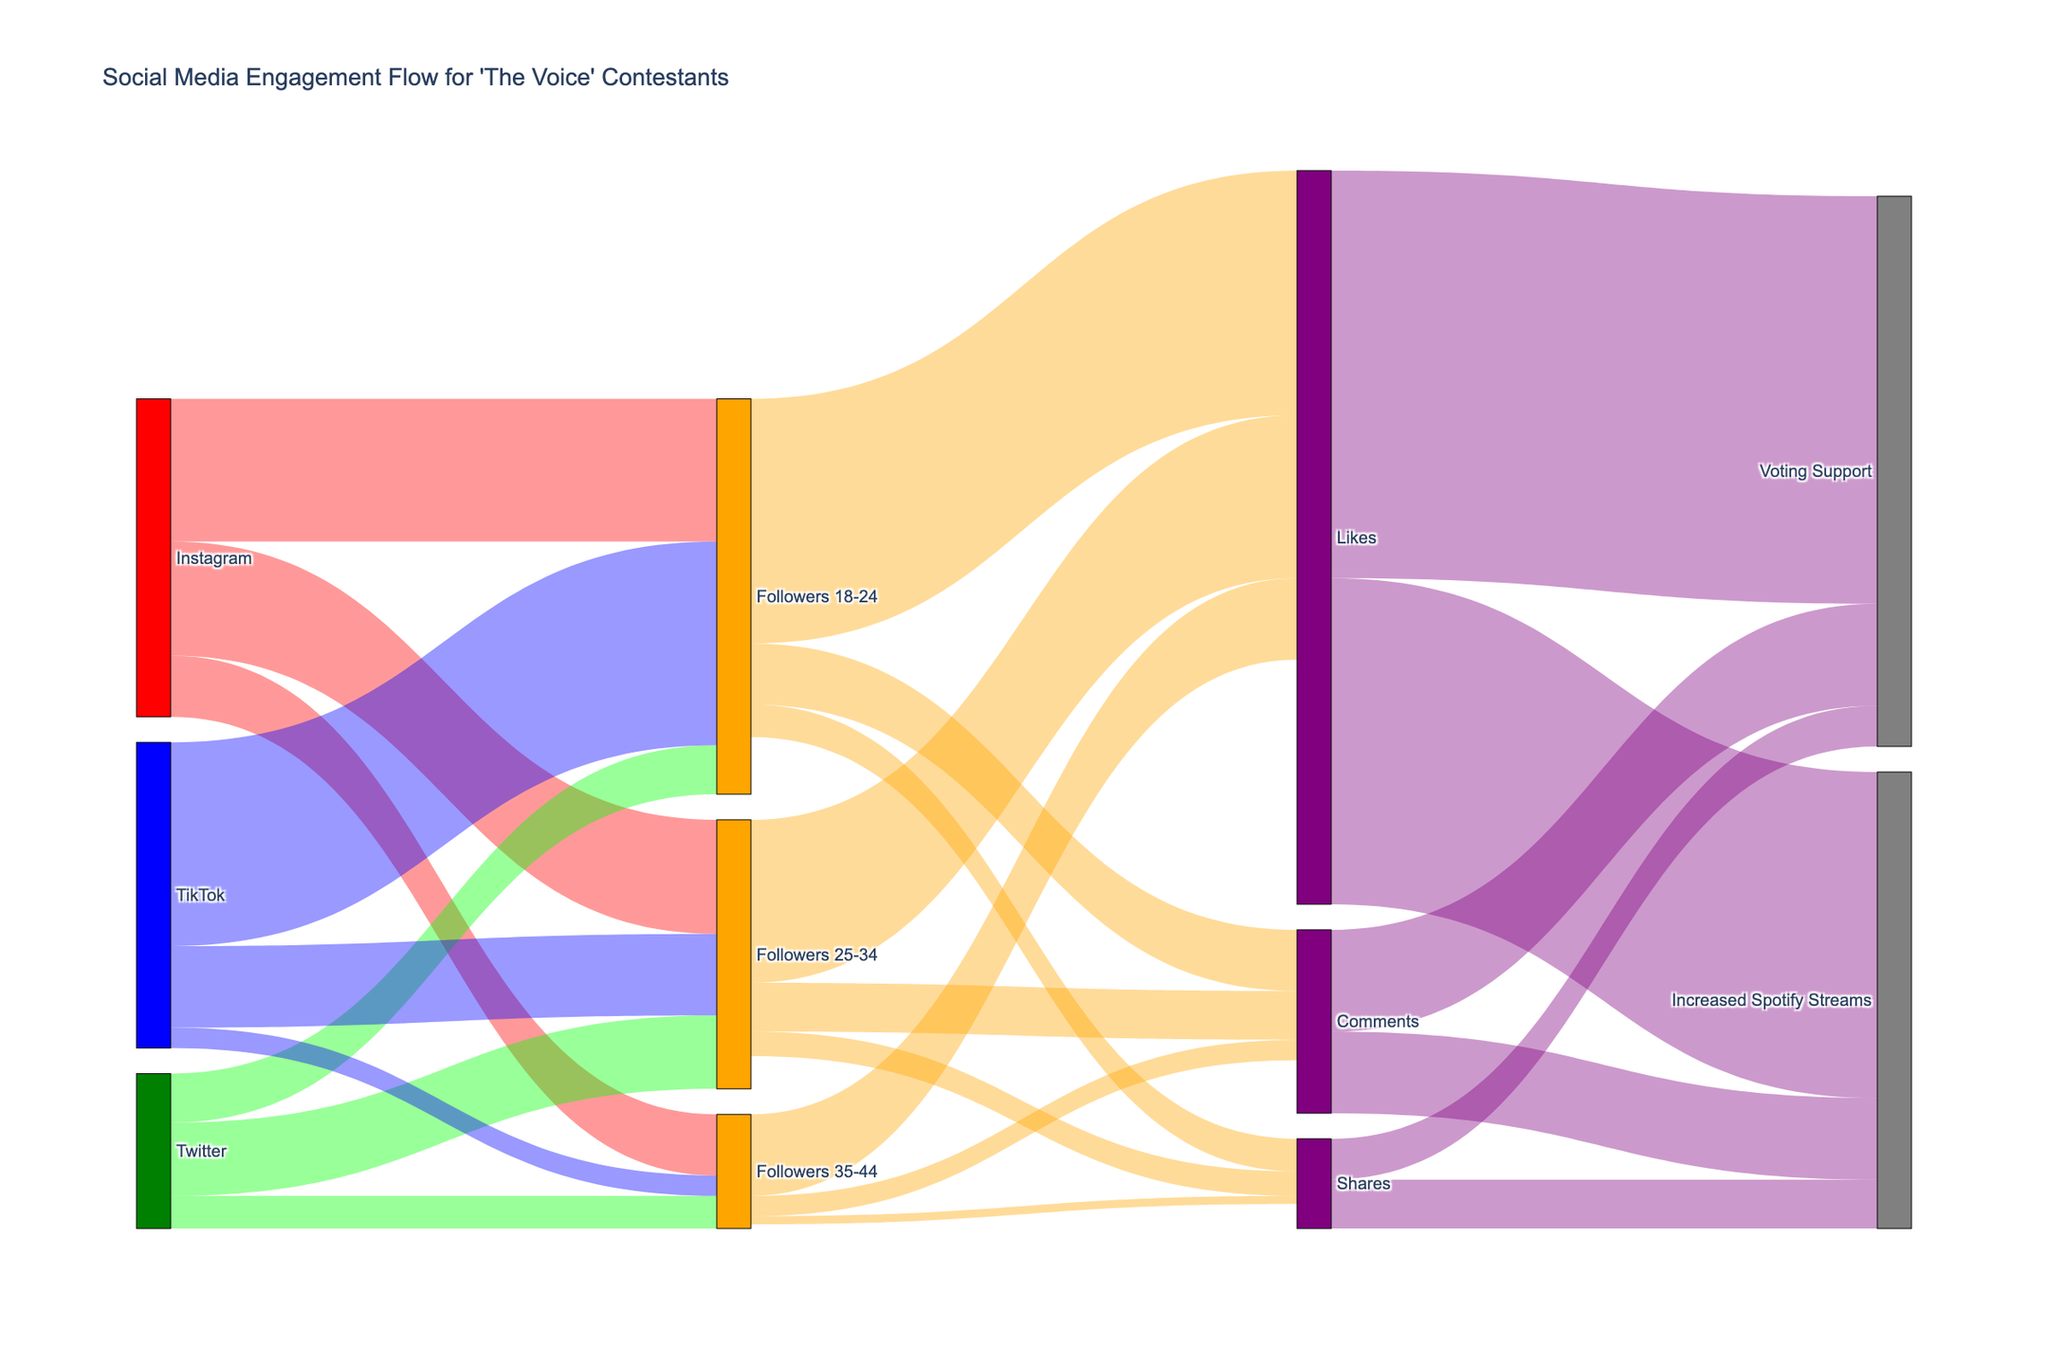What's the title of the diagram? The title is located at the top of the figure.
Answer: Social Media Engagement Flow for 'The Voice' Contestants Which social media platform has the highest number of followers in the 18-24 age group? Look for the platform-to-follower flow related to the 18-24 age group. The values are 35,000 for Instagram, 12,000 for Twitter, and 50,000 for TikTok.
Answer: TikTok How many likes are given by followers aged 25-34 overall? Find the flow values from 'Followers 25-34' to 'Likes'. The value is 40,000.
Answer: 40,000 Compare the number of comments given by followers aged 18-24 to those given by followers aged 35-44. Which group gives more comments? Look at the 'Comments' flow values for 'Followers 18-24' and 'Followers 35-44'. The values are 15,000 and 5,000 respectively.
Answer: Followers 18-24 What is the total number of increased Spotify streams originating from social media interactions? Add the values for 'Increased Spotify Streams' from 'Likes' (80,000), 'Comments' (20,000), and 'Shares' (12,000).
Answer: 112,000 Which age group has the least number of followers across all platforms? Compare the summed values of each age group's flow from all platforms: 
18-24: 35,000 (IG) + 12,000 (TW) + 50,000 (TT) = 97,000
25-34: 28,000 (IG) + 18,000 (TW) + 20,000 (TT) = 66,000
35-44: 15,000 (IG) + 8,000 (TW) + 5,000 (TT) = 28,000
Answer: 35-44 Which type of interaction leads to the highest increase in Spotify streams? Compare the values associated with 'Increased Spotify Streams' for 'Likes', 'Comments', and 'Shares'. The values are 80,000, 20,000, and 12,000 respectively.
Answer: Likes Do followers aged 25-34 give more shares or comments? Compare the values for 'Shares' and 'Comments' for 'Followers 25-34'. The values are 6,000 and 12,000 respectively.
Answer: Comments What is the combined value of votes received through all types of interactions? Add the values for 'Voting Support' from 'Likes' (100,000), 'Comments' (25,000), and 'Shares' (10,000).
Answer: 135,000 